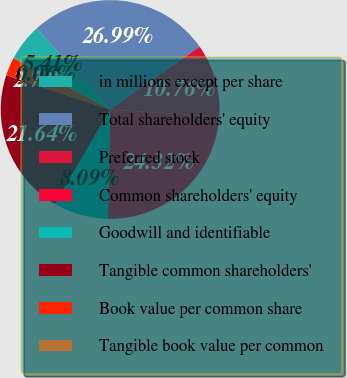<chart> <loc_0><loc_0><loc_500><loc_500><pie_chart><fcel>in millions except per share<fcel>Total shareholders' equity<fcel>Preferred stock<fcel>Common shareholders' equity<fcel>Goodwill and identifiable<fcel>Tangible common shareholders'<fcel>Book value per common share<fcel>Tangible book value per common<nl><fcel>5.41%<fcel>26.99%<fcel>10.76%<fcel>24.32%<fcel>8.09%<fcel>21.64%<fcel>2.73%<fcel>0.06%<nl></chart> 